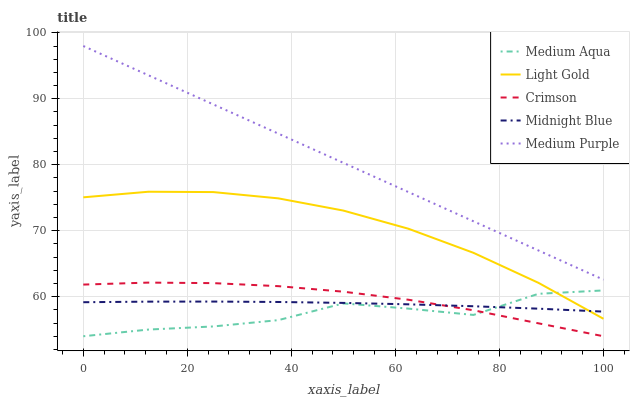Does Medium Aqua have the minimum area under the curve?
Answer yes or no. Yes. Does Medium Purple have the maximum area under the curve?
Answer yes or no. Yes. Does Light Gold have the minimum area under the curve?
Answer yes or no. No. Does Light Gold have the maximum area under the curve?
Answer yes or no. No. Is Medium Purple the smoothest?
Answer yes or no. Yes. Is Medium Aqua the roughest?
Answer yes or no. Yes. Is Light Gold the smoothest?
Answer yes or no. No. Is Light Gold the roughest?
Answer yes or no. No. Does Crimson have the lowest value?
Answer yes or no. Yes. Does Light Gold have the lowest value?
Answer yes or no. No. Does Medium Purple have the highest value?
Answer yes or no. Yes. Does Light Gold have the highest value?
Answer yes or no. No. Is Crimson less than Light Gold?
Answer yes or no. Yes. Is Medium Purple greater than Midnight Blue?
Answer yes or no. Yes. Does Medium Aqua intersect Light Gold?
Answer yes or no. Yes. Is Medium Aqua less than Light Gold?
Answer yes or no. No. Is Medium Aqua greater than Light Gold?
Answer yes or no. No. Does Crimson intersect Light Gold?
Answer yes or no. No. 